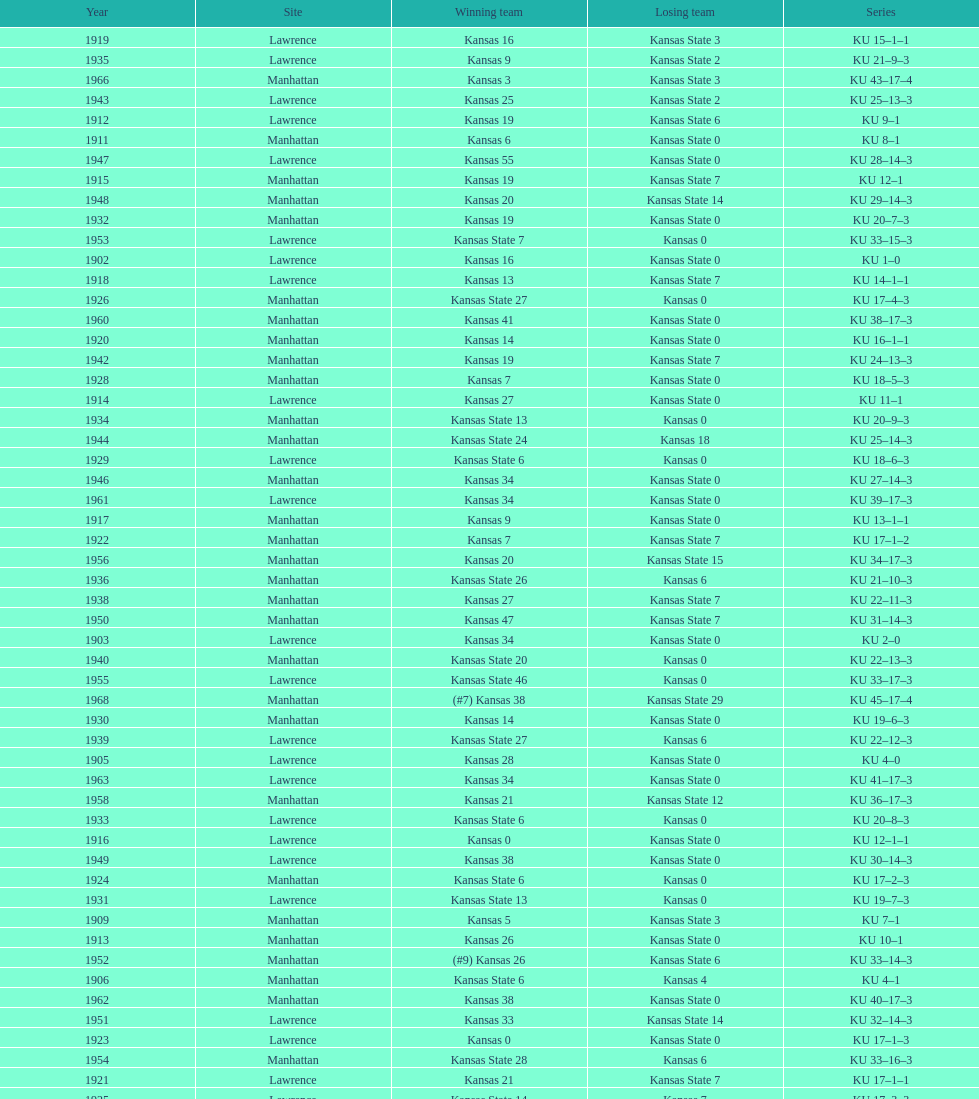How many times did kansas and kansas state play in lawrence from 1902-1968? 34. 